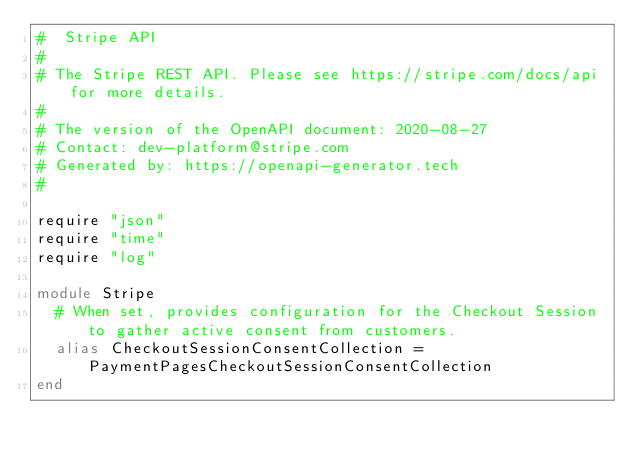Convert code to text. <code><loc_0><loc_0><loc_500><loc_500><_Crystal_>#  Stripe API
#
# The Stripe REST API. Please see https://stripe.com/docs/api for more details.
#
# The version of the OpenAPI document: 2020-08-27
# Contact: dev-platform@stripe.com
# Generated by: https://openapi-generator.tech
#

require "json"
require "time"
require "log"

module Stripe
  # When set, provides configuration for the Checkout Session to gather active consent from customers.
  alias CheckoutSessionConsentCollection = PaymentPagesCheckoutSessionConsentCollection
end
</code> 